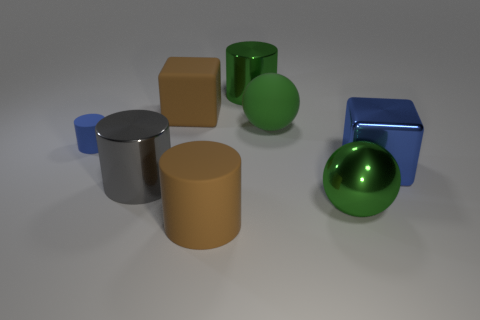Add 1 large matte objects. How many objects exist? 9 Subtract all balls. How many objects are left? 6 Add 6 large brown matte cylinders. How many large brown matte cylinders are left? 7 Add 4 tiny brown metal objects. How many tiny brown metal objects exist? 4 Subtract 1 green balls. How many objects are left? 7 Subtract all gray spheres. Subtract all tiny blue matte objects. How many objects are left? 7 